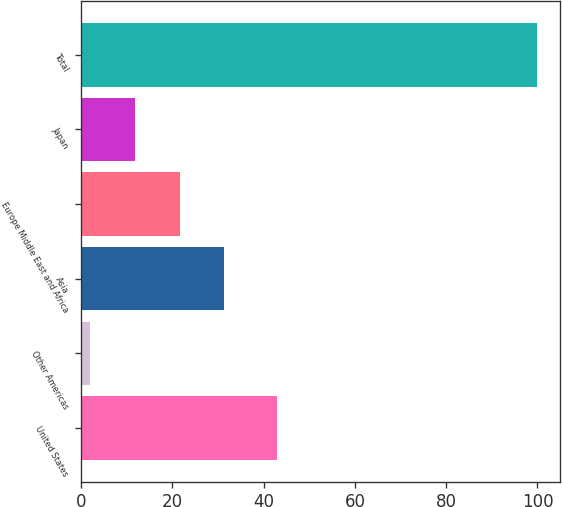Convert chart to OTSL. <chart><loc_0><loc_0><loc_500><loc_500><bar_chart><fcel>United States<fcel>Other Americas<fcel>Asia<fcel>Europe Middle East and Africa<fcel>Japan<fcel>Total<nl><fcel>43<fcel>2<fcel>31.4<fcel>21.6<fcel>11.8<fcel>100<nl></chart> 